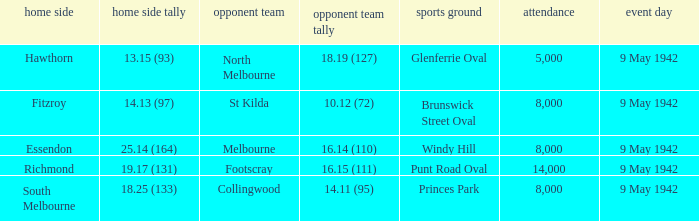How large was the crowd with a home team score of 18.25 (133)? 8000.0. 